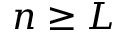<formula> <loc_0><loc_0><loc_500><loc_500>n \geq L</formula> 